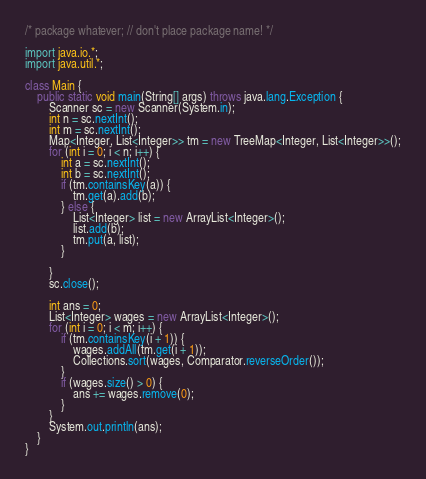<code> <loc_0><loc_0><loc_500><loc_500><_Java_>
/* package whatever; // don't place package name! */

import java.io.*;
import java.util.*;

class Main {
    public static void main(String[] args) throws java.lang.Exception {
        Scanner sc = new Scanner(System.in);
        int n = sc.nextInt();
        int m = sc.nextInt();
        Map<Integer, List<Integer>> tm = new TreeMap<Integer, List<Integer>>();
        for (int i = 0; i < n; i++) {
            int a = sc.nextInt();
            int b = sc.nextInt();
            if (tm.containsKey(a)) {
                tm.get(a).add(b);
            } else {
                List<Integer> list = new ArrayList<Integer>();
                list.add(b);
                tm.put(a, list);
            }

        }
        sc.close();

        int ans = 0;
        List<Integer> wages = new ArrayList<Integer>();
        for (int i = 0; i < m; i++) {
            if (tm.containsKey(i + 1)) {
                wages.addAll(tm.get(i + 1));
                Collections.sort(wages, Comparator.reverseOrder());
            }
            if (wages.size() > 0) {
                ans += wages.remove(0);
            }
        }
        System.out.println(ans);
    }
}
</code> 